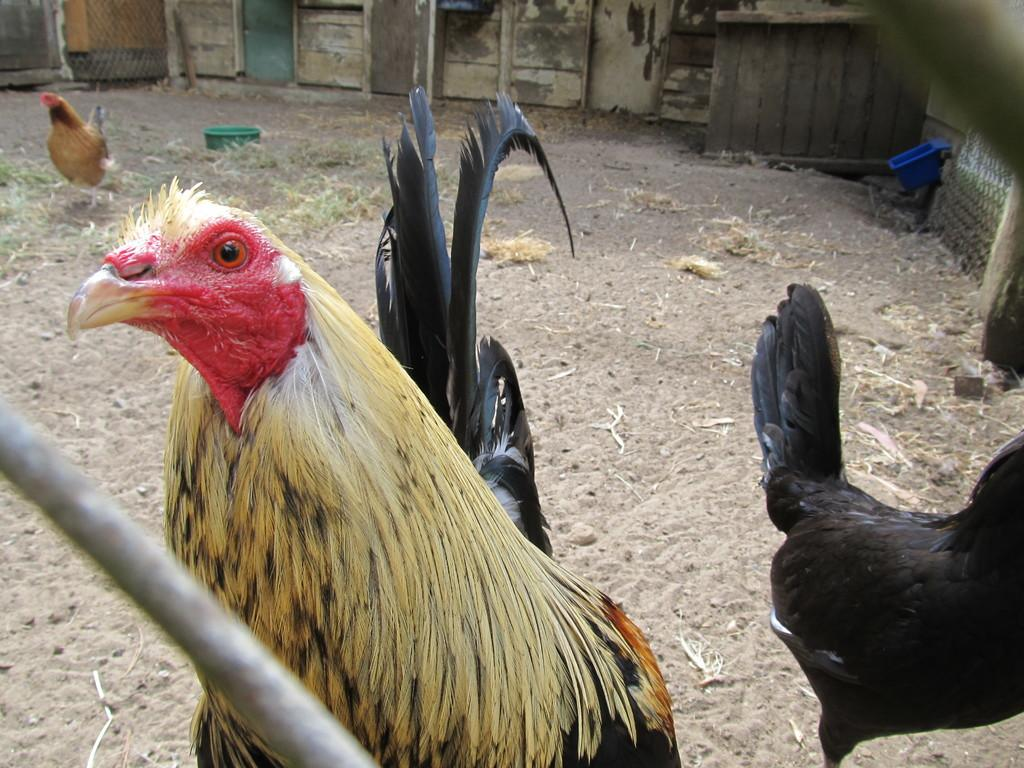What type of animals can be seen on the ground in the image? There are hens on the ground in the image. What type of vegetation is visible in the image? There is grass visible in the image. What object is present in the image that might be used for holding or carrying items? Baskets are in the image. What architectural feature can be seen in the background of the image? There is a wall in the background of the image. What type of payment is required to access the sugar in the image? There is no sugar present in the image, and therefore no payment is required. 